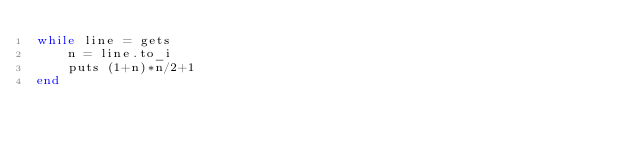Convert code to text. <code><loc_0><loc_0><loc_500><loc_500><_Ruby_>while line = gets
    n = line.to_i
    puts (1+n)*n/2+1
end
</code> 